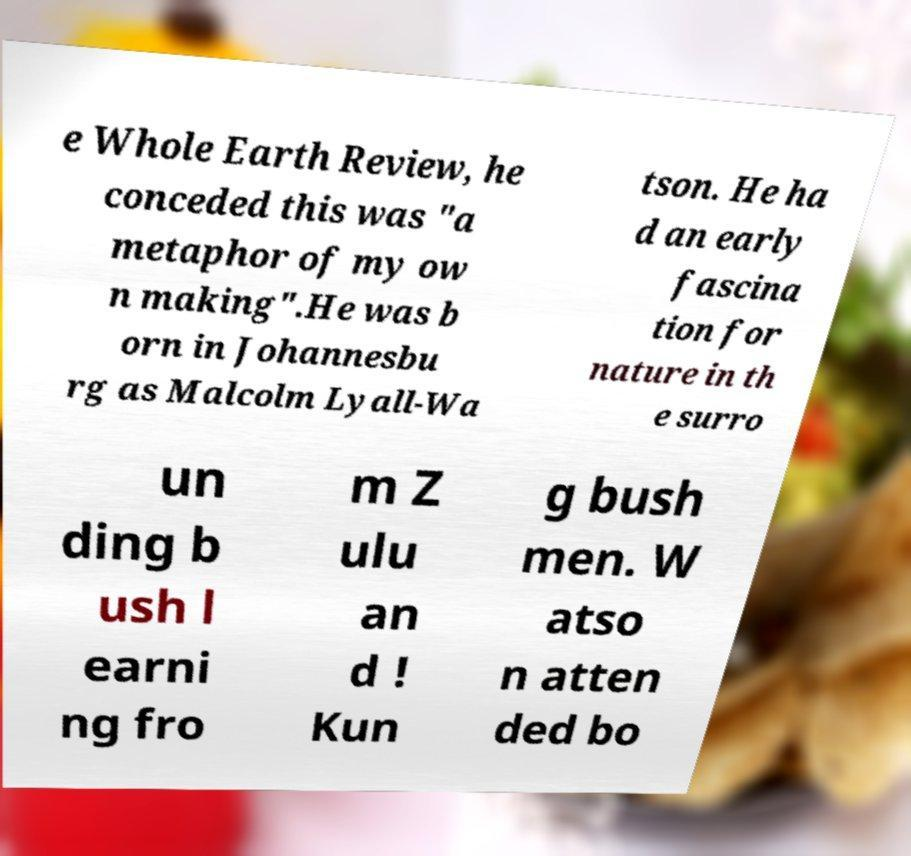Can you accurately transcribe the text from the provided image for me? e Whole Earth Review, he conceded this was "a metaphor of my ow n making".He was b orn in Johannesbu rg as Malcolm Lyall-Wa tson. He ha d an early fascina tion for nature in th e surro un ding b ush l earni ng fro m Z ulu an d ! Kun g bush men. W atso n atten ded bo 